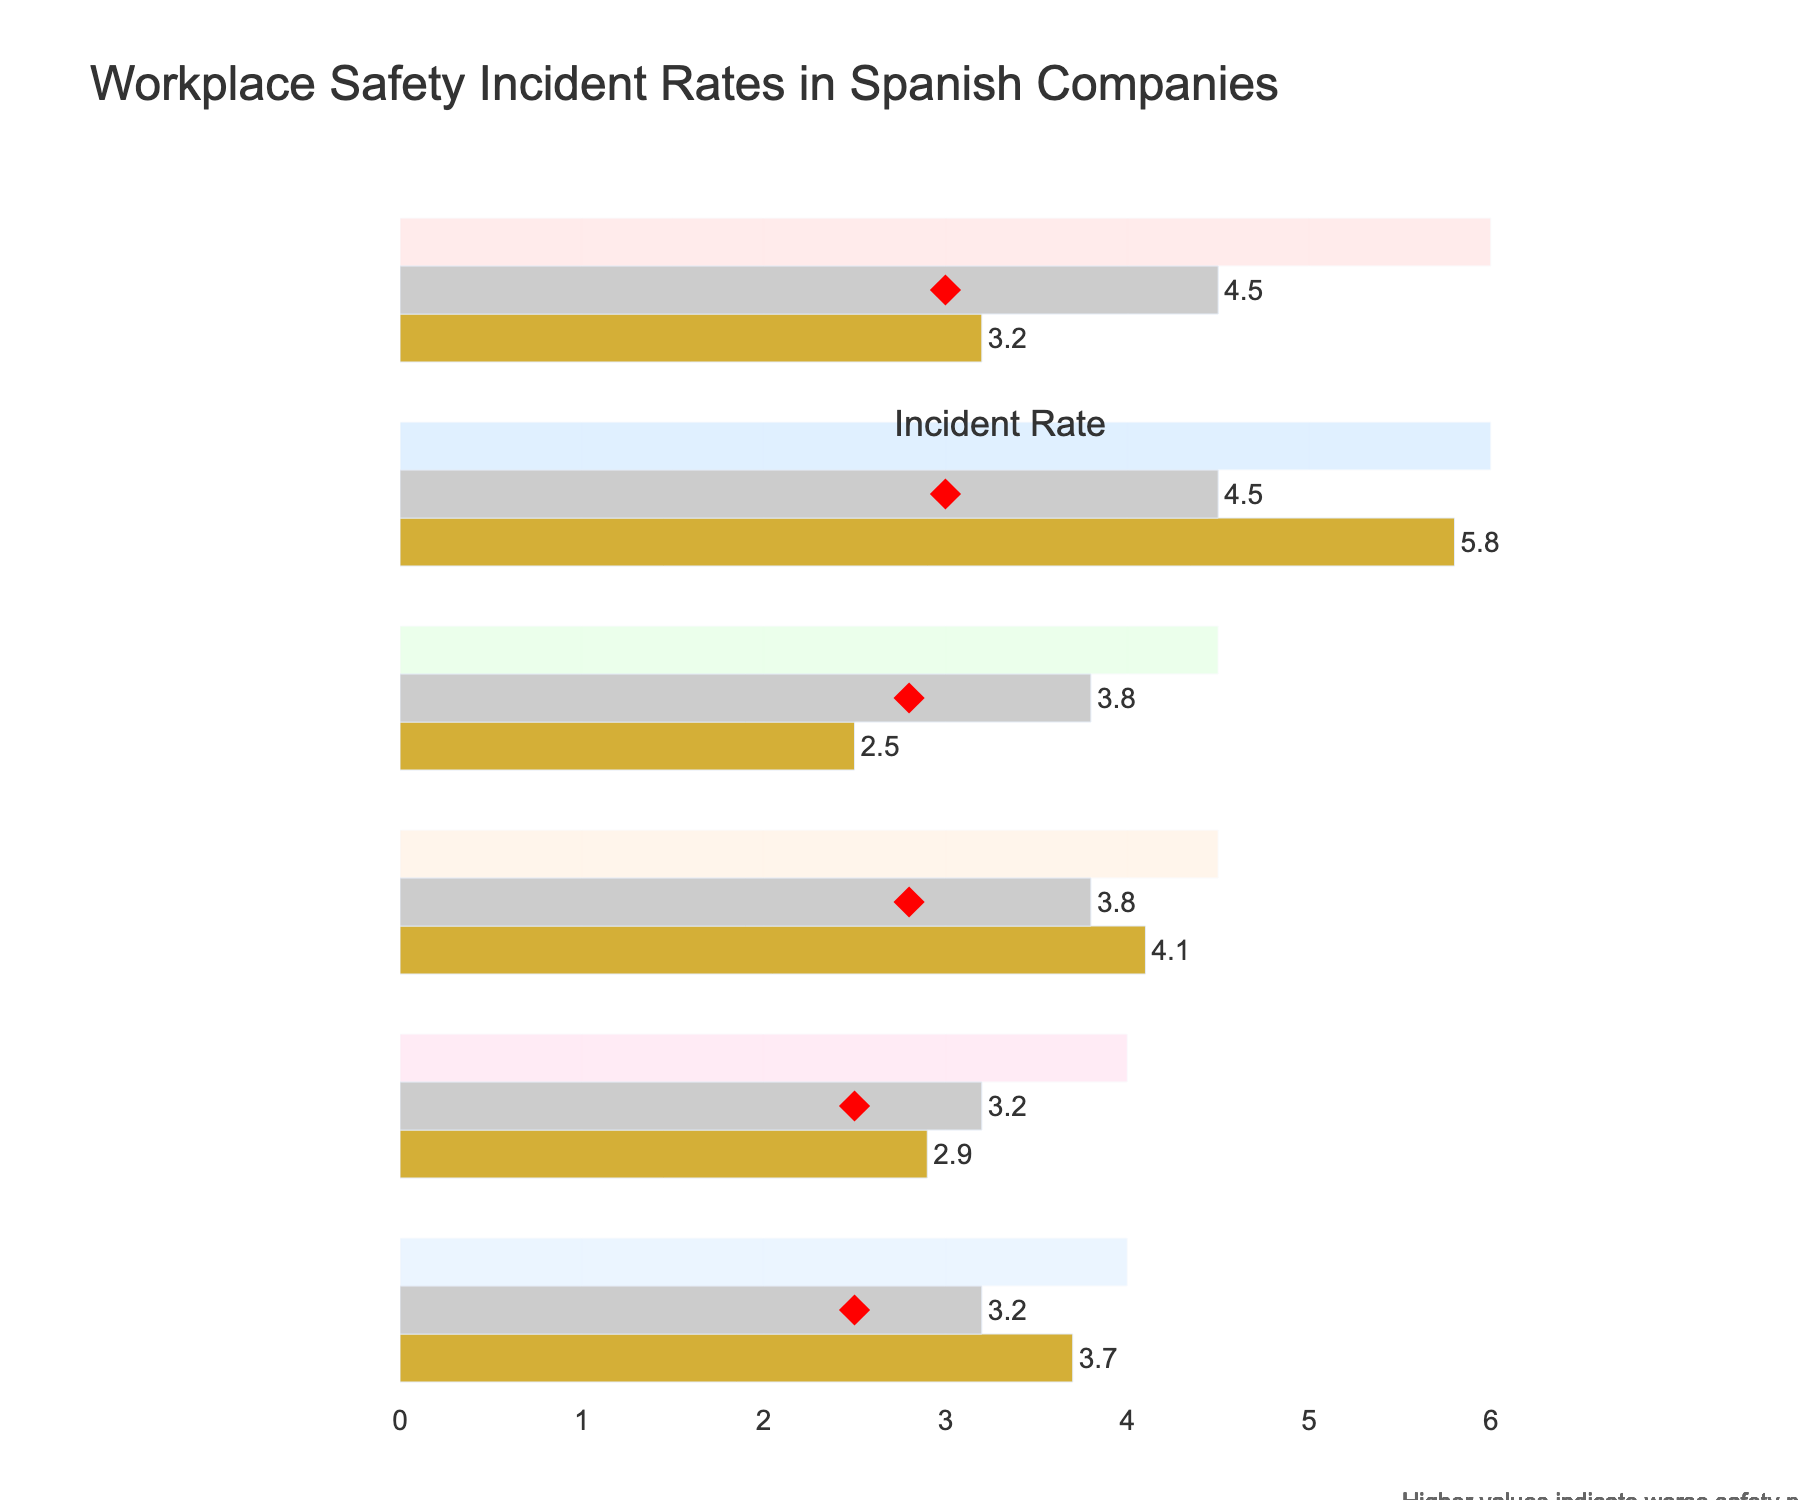What is the title of the figure? The title of the figure can be found at the top center of the chart.
Answer: Workplace Safety Incident Rates in Spanish Companies What is the incident rate for unionized construction companies? Look for the bullet labeled "Unionized Construction" and identify the value marked as "Actual" in gold next to it.
Answer: 3.2 Which category has the largest difference between the actual incident rate and the target? To find this, compare the difference between the "Actual" and "Target" values for each category, and identify the biggest gap.
Answer: Non-unionized Construction Compare the actual incident rates for unionized and non-unionized transportation companies. Which one is higher? Locate the "Unionized Transportation" and "Non-unionized Transportation" categories. Compare the actual incident rate values (gold bars).
Answer: Non-unionized Transportation How do unionized versus non-unionized manufacturing companies perform relative to the industry average? For both "Unionized Manufacturing" and "Non-unionized Manufacturing" categories, compare their actual incident rate (gold bar) to the industry average (gray bar).
Answer: Unionized better, Non-unionized worse Which category in the chart has the lowest actual incident rate? Identify the smallest value among all the gold-colored bars labeled as "Actual".
Answer: Unionized Manufacturing Are there any categories where the actual incident rate is below the target? Compare all "Actual" values (gold bars) with their corresponding "Target" values (red diamond).
Answer: No, all actual rates are above their targets What is the range (between which values) for the Unionized Construction company's incident rate target? Identify the "Range1" and "Range3" values associated with "Unionized Construction".
Answer: Between 2.0 and 6.0 How do the incident rates in non-unionized construction compare to the upper bound of their range? Observe the actual incident rate for "Non-unionized Construction" and compare it to the highest range value (light colored bar).
Answer: Slightly below it 